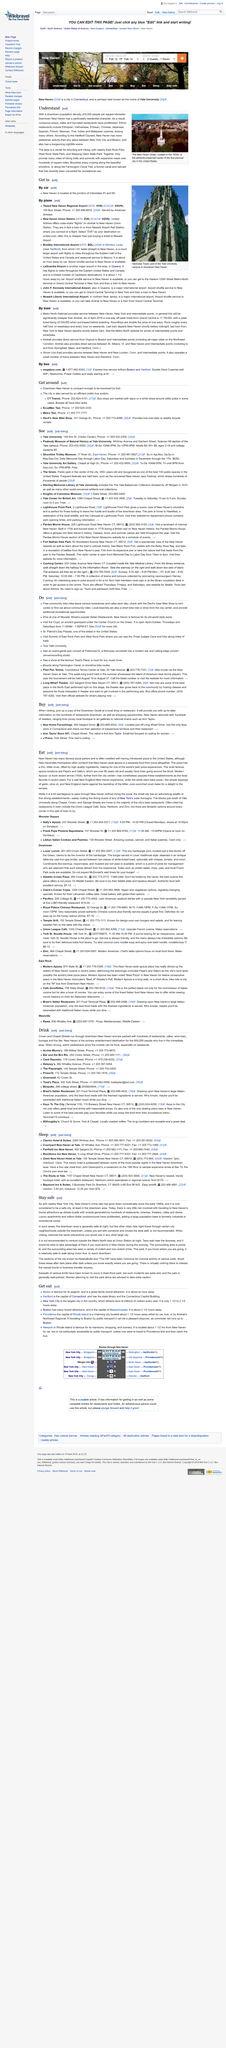Mention a couple of crucial points in this snapshot. The photograph shows the New Haven Green, which displays a green color that is different from the green shown in the photograph. Yes, the Anne Taylor Store is the nation's first Ann Taylor, making it the pioneer in the retail industry. Downtown New Haven has a population of approximately 6,000 people. The article does not recommend traveling through city neighborhoods outside of downtown New Haven at night. The last train from New York to New Haven departs at 2:00 a.m. 